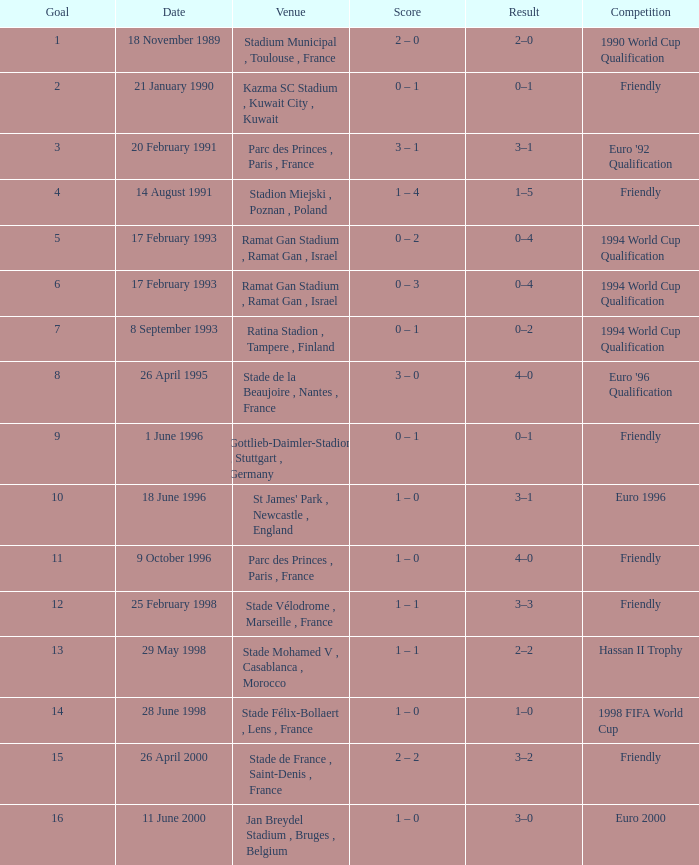What was the date of the game with a result of 3–2? 26 April 2000. 